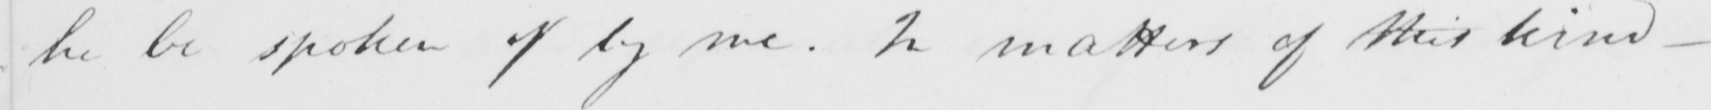Can you tell me what this handwritten text says? he be spoken of by me . In matters of this kind - 